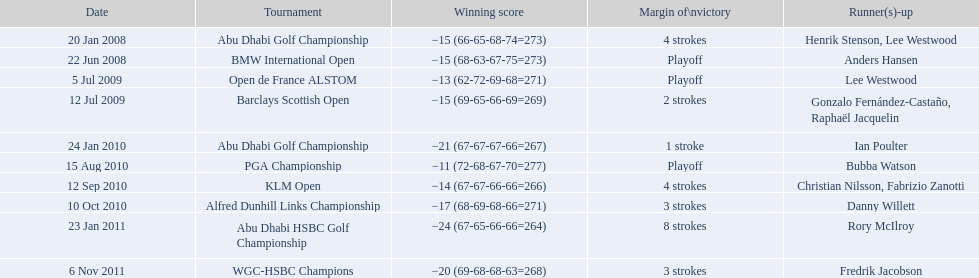How long separated the playoff victory at bmw international open and the 4 stroke victory at the klm open? 2 years. 